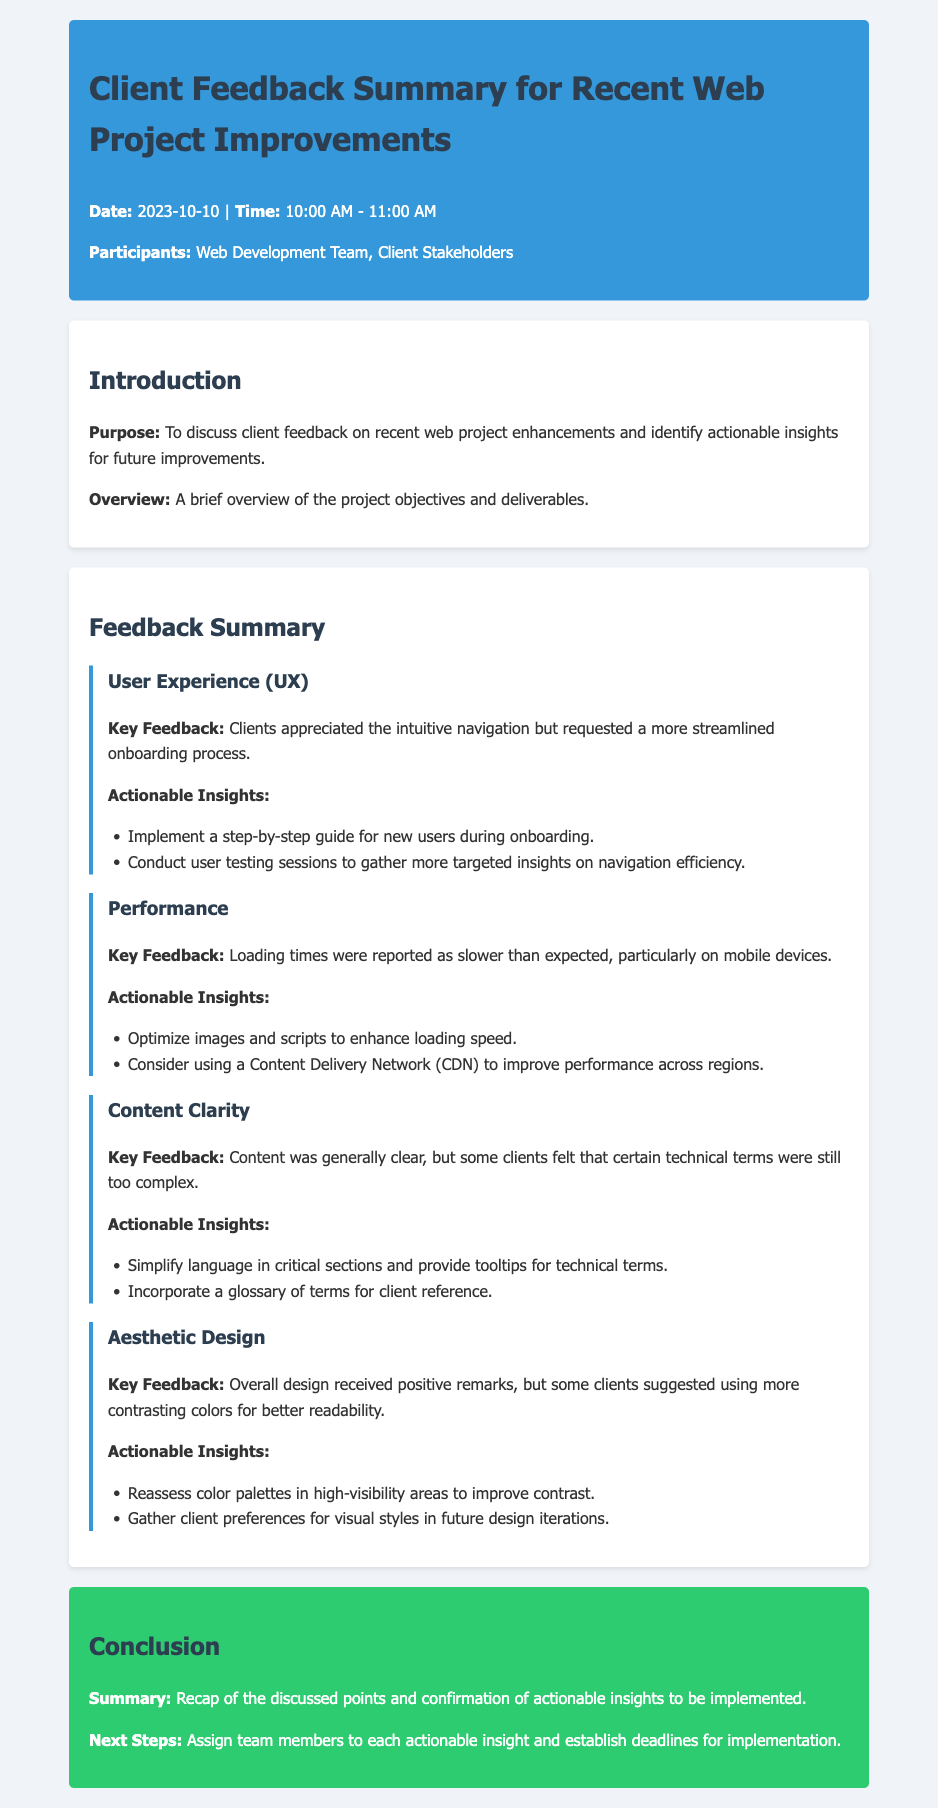What is the date of the feedback summary meeting? The date of the meeting is mentioned in the header of the document.
Answer: 2023-10-10 Who were the participants in the meeting? The participants list includes the Web Development Team and Client Stakeholders.
Answer: Web Development Team, Client Stakeholders What was a key feedback point regarding User Experience? Key feedback related to User Experience is stated explicitly in its section.
Answer: More streamlined onboarding process What actionable insight was suggested for performance improvement? The section on performance provides specific actionable insights.
Answer: Optimize images and scripts to enhance loading speed What was the client's feedback on aesthetic design? This feedback is summarized in the feedback item for aesthetic design.
Answer: More contrasting colors for better readability How many actionable insights were listed under Content Clarity? The number of insights can be counted from the provided list under Content Clarity.
Answer: Two What was the main purpose of the meeting? The purpose of the meeting is outlined in the introduction section.
Answer: To discuss client feedback on recent web project enhancements What is stated as the next step after the meeting? The next steps are mentioned in the conclusion section.
Answer: Assign team members to each actionable insight What did clients appreciate about the navigation? The positive feedback is stated in the User Experience section.
Answer: Intuitive navigation 